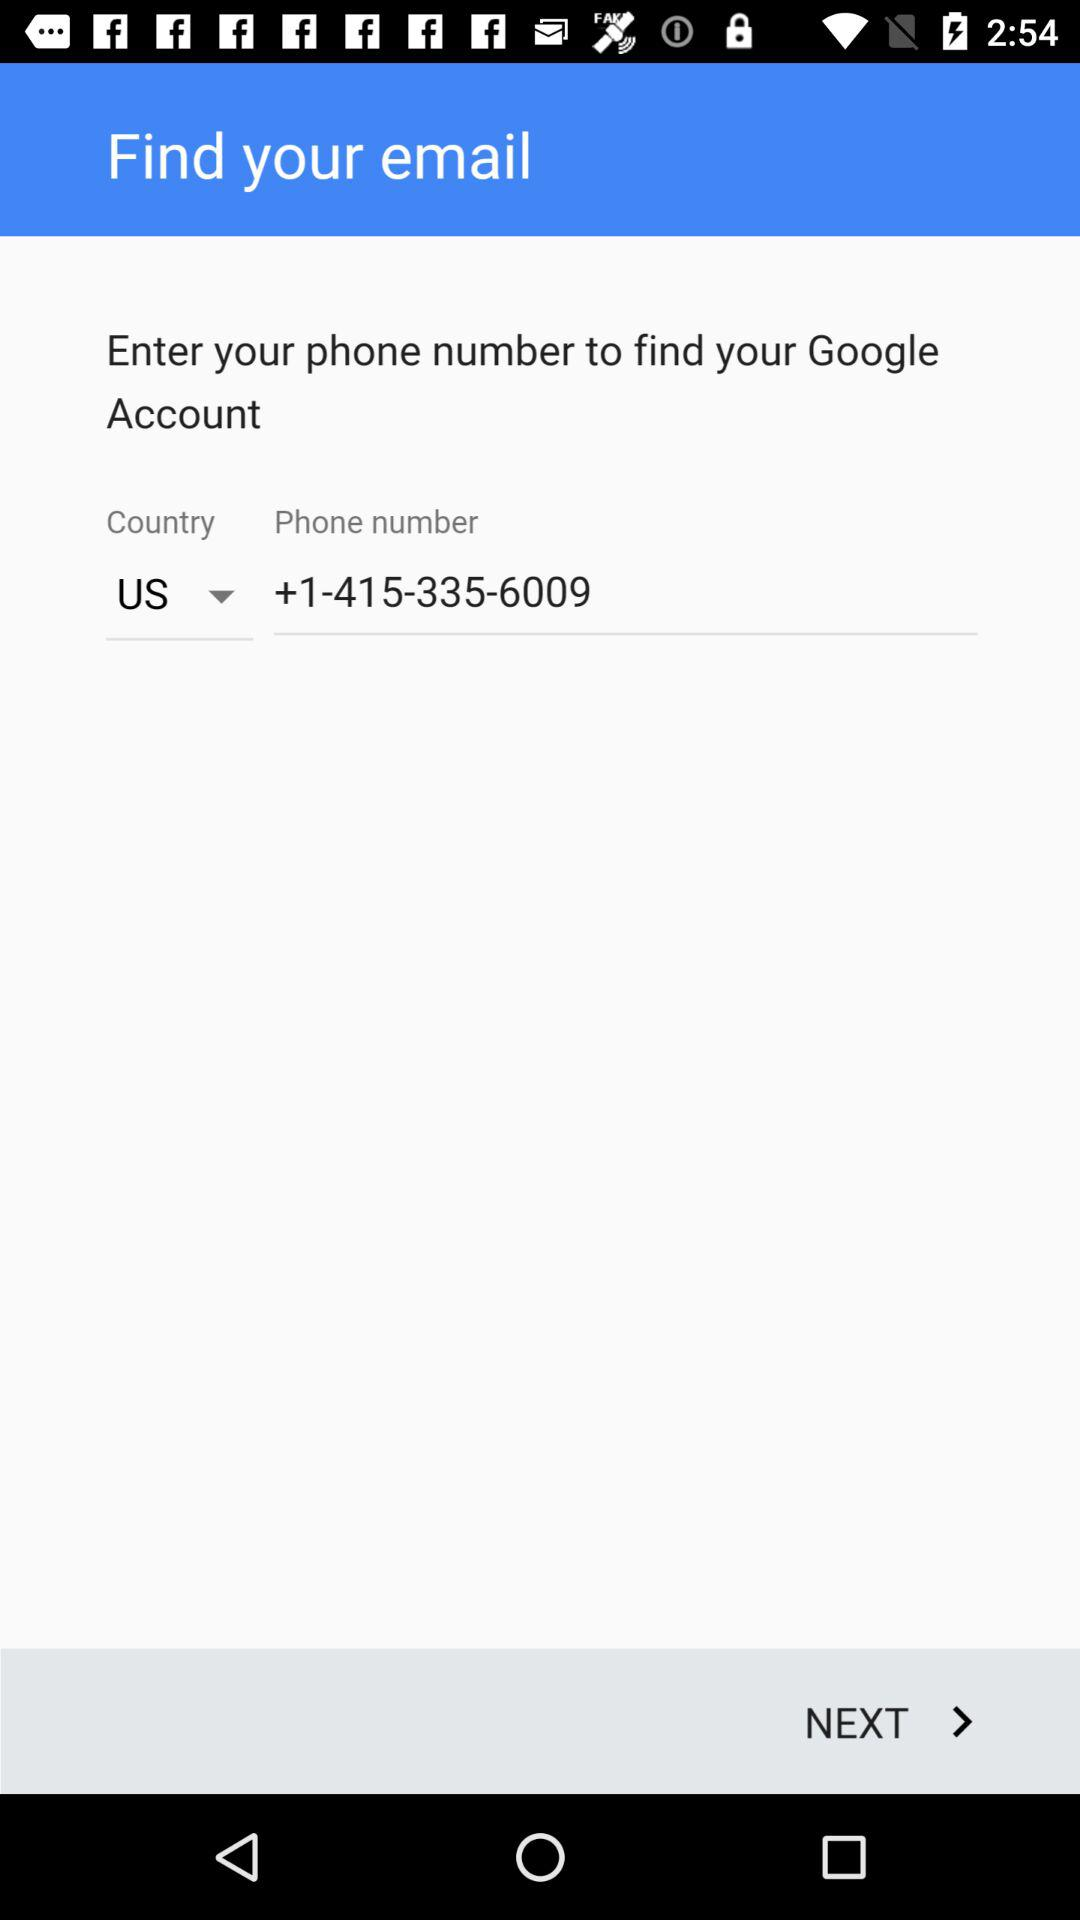What is the number? The number is +1-415-335-6009. 